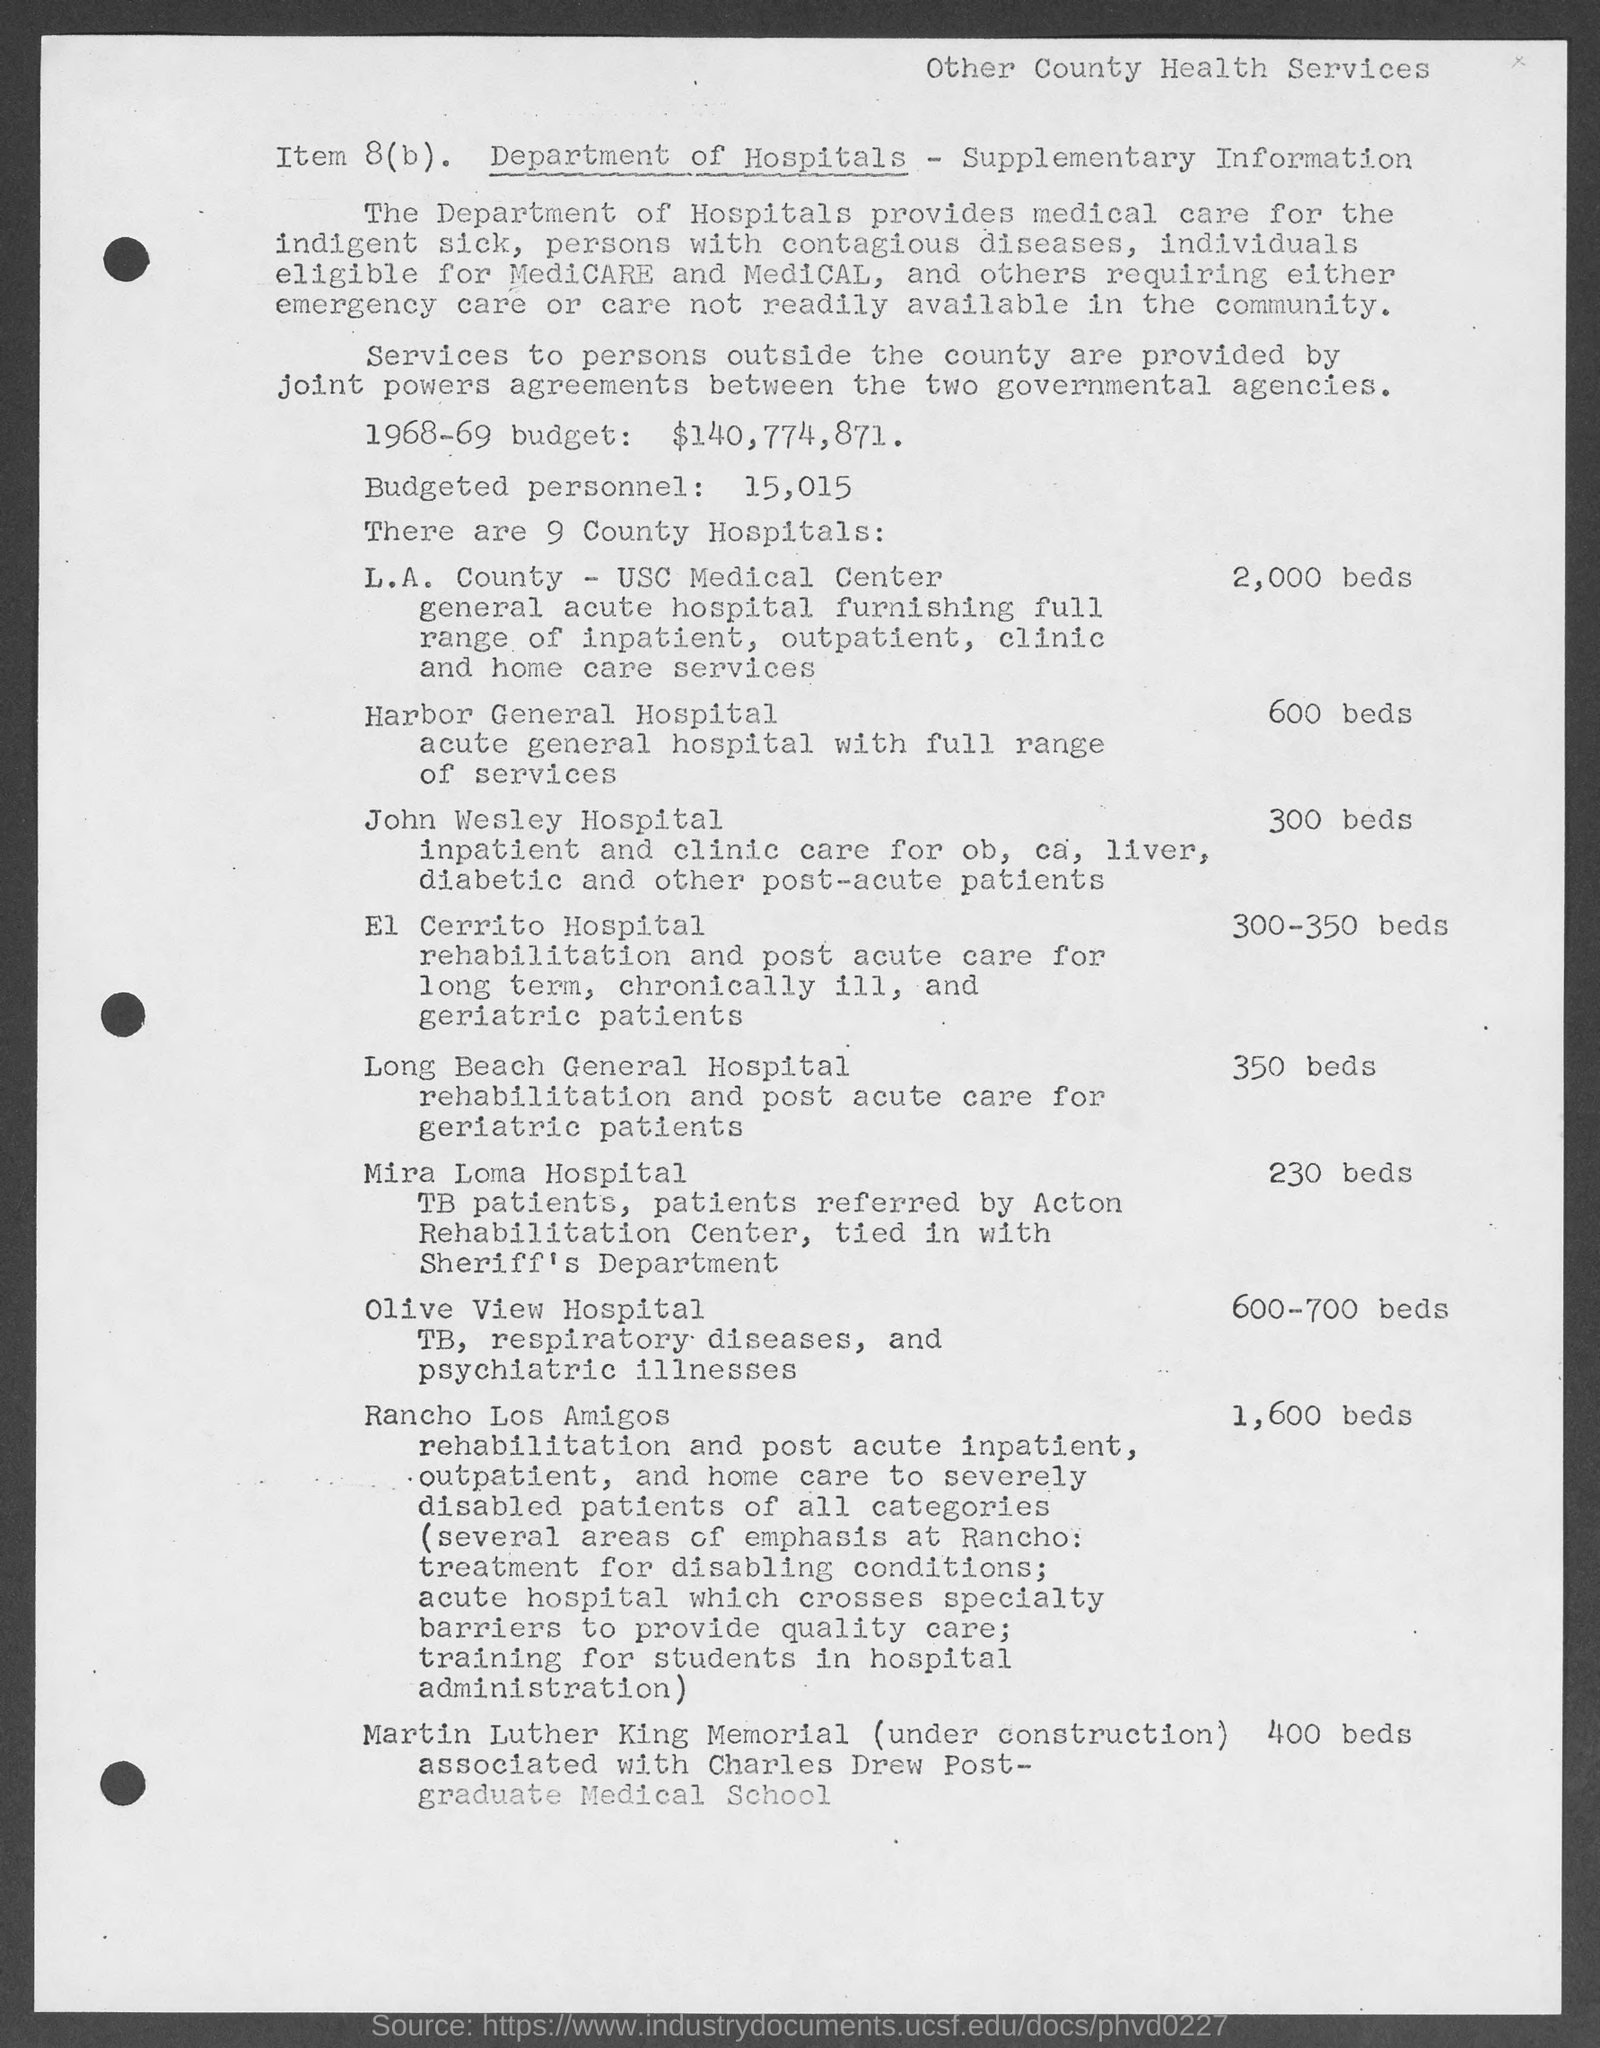Indicate a few pertinent items in this graphic. There are approximately 2,000 available beds for use at the L.A. County - USC Medical Center. The Harbor General Hospital has a total of 600 available beds. 